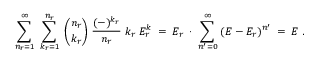<formula> <loc_0><loc_0><loc_500><loc_500>\ \sum _ { n _ { r } = 1 } ^ { \infty } \, \sum _ { k _ { r } = 1 } ^ { n _ { r } } \, { \binom { n _ { r } } { k _ { r } } } \, \frac { ( - ) ^ { k _ { r } } } { n _ { r } } \, k _ { r } \, E _ { r } ^ { k } \, = \, E _ { r } \, \cdot \, \sum _ { n ^ { \prime } = 0 } ^ { \infty } \, ( E - E _ { r } ) ^ { n ^ { \prime } } \, = \, E \, .</formula> 